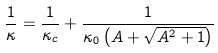<formula> <loc_0><loc_0><loc_500><loc_500>\frac { 1 } { \kappa } = \frac { 1 } { \kappa _ { c } } + \frac { 1 } { \kappa _ { 0 } \left ( A + \sqrt { A ^ { 2 } + 1 } \right ) }</formula> 